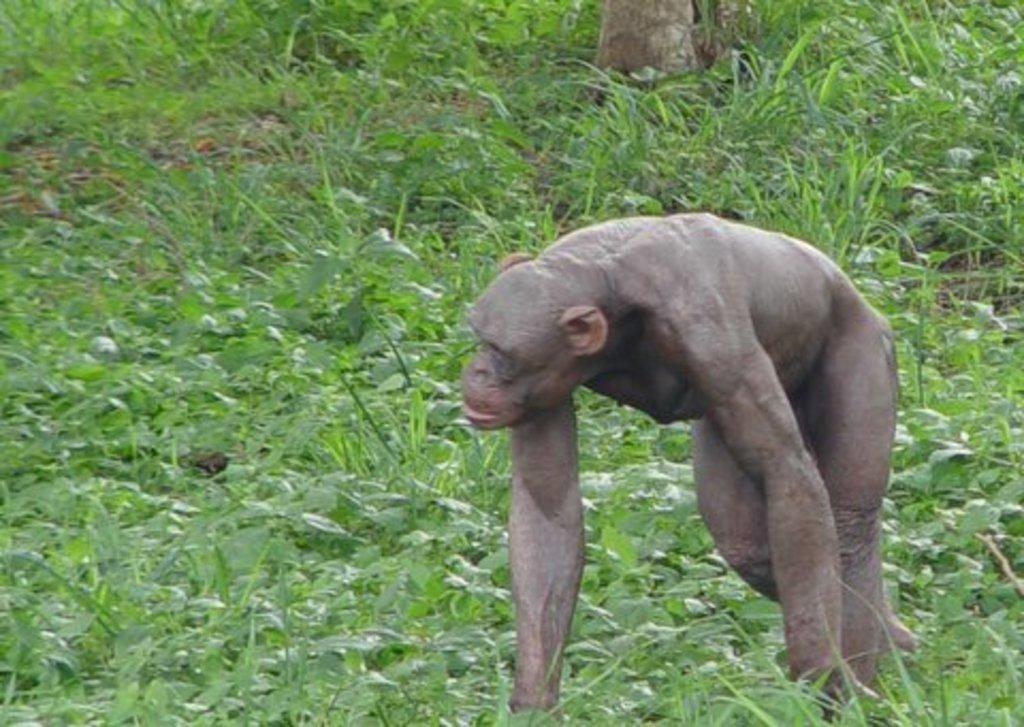Could you give a brief overview of what you see in this image? In this image, we can see a monkey walking. In the background, there is ground, covered with plants. 